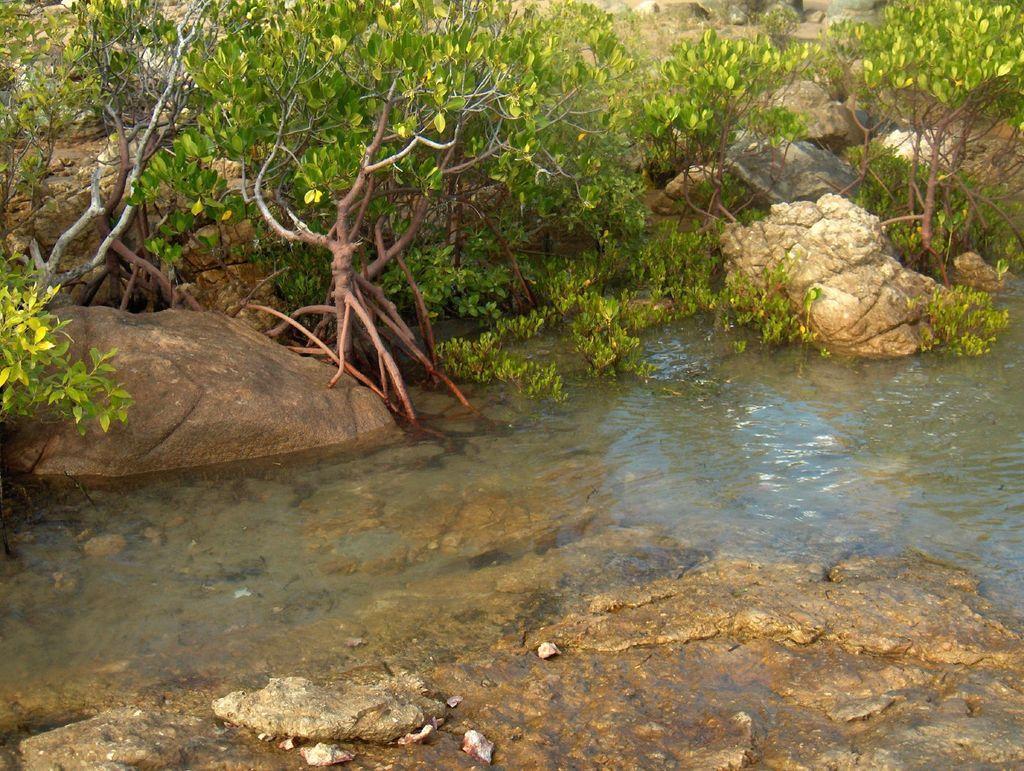How would you summarize this image in a sentence or two? In this image I can see rocks, trees and mountains. This image is taken may be near the lake. 